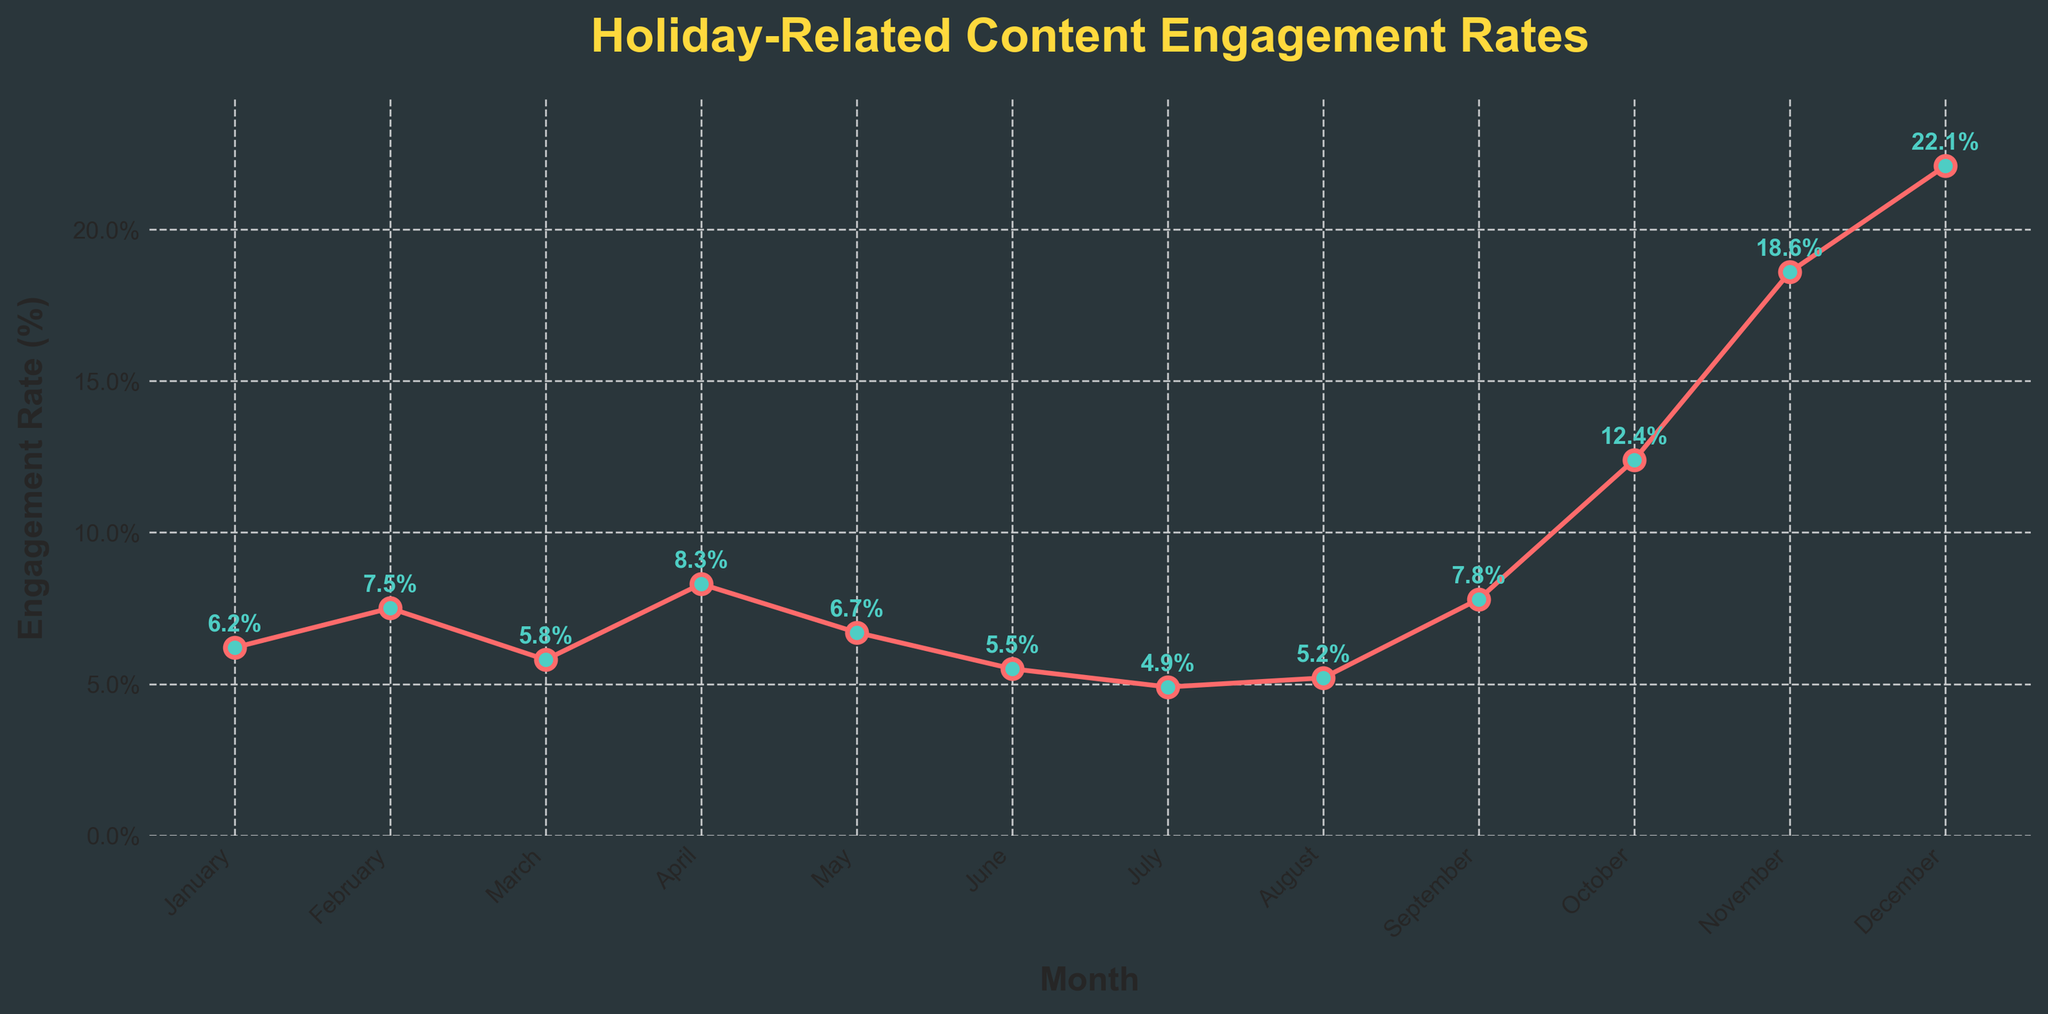What is the month with the highest engagement rate? When looking at the chart, you can see that December has the highest point on the line graph, indicating it has the highest engagement rate of 22.1%.
Answer: December Which two months have the closest engagement rates, and what are those rates? By visually inspecting the line chart's proximity of points, May and June have the closest engagement rates: 6.7% and 5.5%, respectively.
Answer: May and June Which quarter (3-month period) of the year has the highest average engagement rate? Divide the year into quarters (Q1: Jan-Mar, Q2: Apr-Jun, Q3: Jul-Sep, Q4: Oct-Dec). Calculate the average engagement rate for each. Q1: (6.2 + 7.5 + 5.8)/3 = 6.5%, Q2: (8.3 + 6.7 + 5.5)/3 = 6.83%, Q3: (4.9 + 5.2 + 7.8)/3 = 5.97%, Q4: (12.4 + 18.6 + 22.1)/3 = 17.7%. Q4 has the highest average engagement rate.
Answer: Q4 What is the difference in engagement rate between February and August? Observe February's engagement rate (7.5%) and August's engagement rate (5.2%). Calculate the difference: 7.5% - 5.2% = 2.3%.
Answer: 2.3% During which month does the engagement rate first exceed 10%? The first time the line crosses the 10% mark is in October.
Answer: October Which month has the lowest engagement rate, and what is the rate? By examining the dips in the line chart, July has the lowest engagement rate at 4.9%.
Answer: July What is the combined engagement rate for the months of October, November, and December? Add the engagement rates for these months: 12.4% + 18.6% + 22.1% = 53.1%.
Answer: 53.1% Between January and September, in which months does the engagement rate decrease compared to the previous month? Comparing sequential months: Engagement decreases from February (7.5%) to March (5.8%), April (8.3%) to May (6.7%), and May (6.7%) to June (5.5%). No decreases occur from June to September. So, the months are March, May, and June.
Answer: March, May, June 